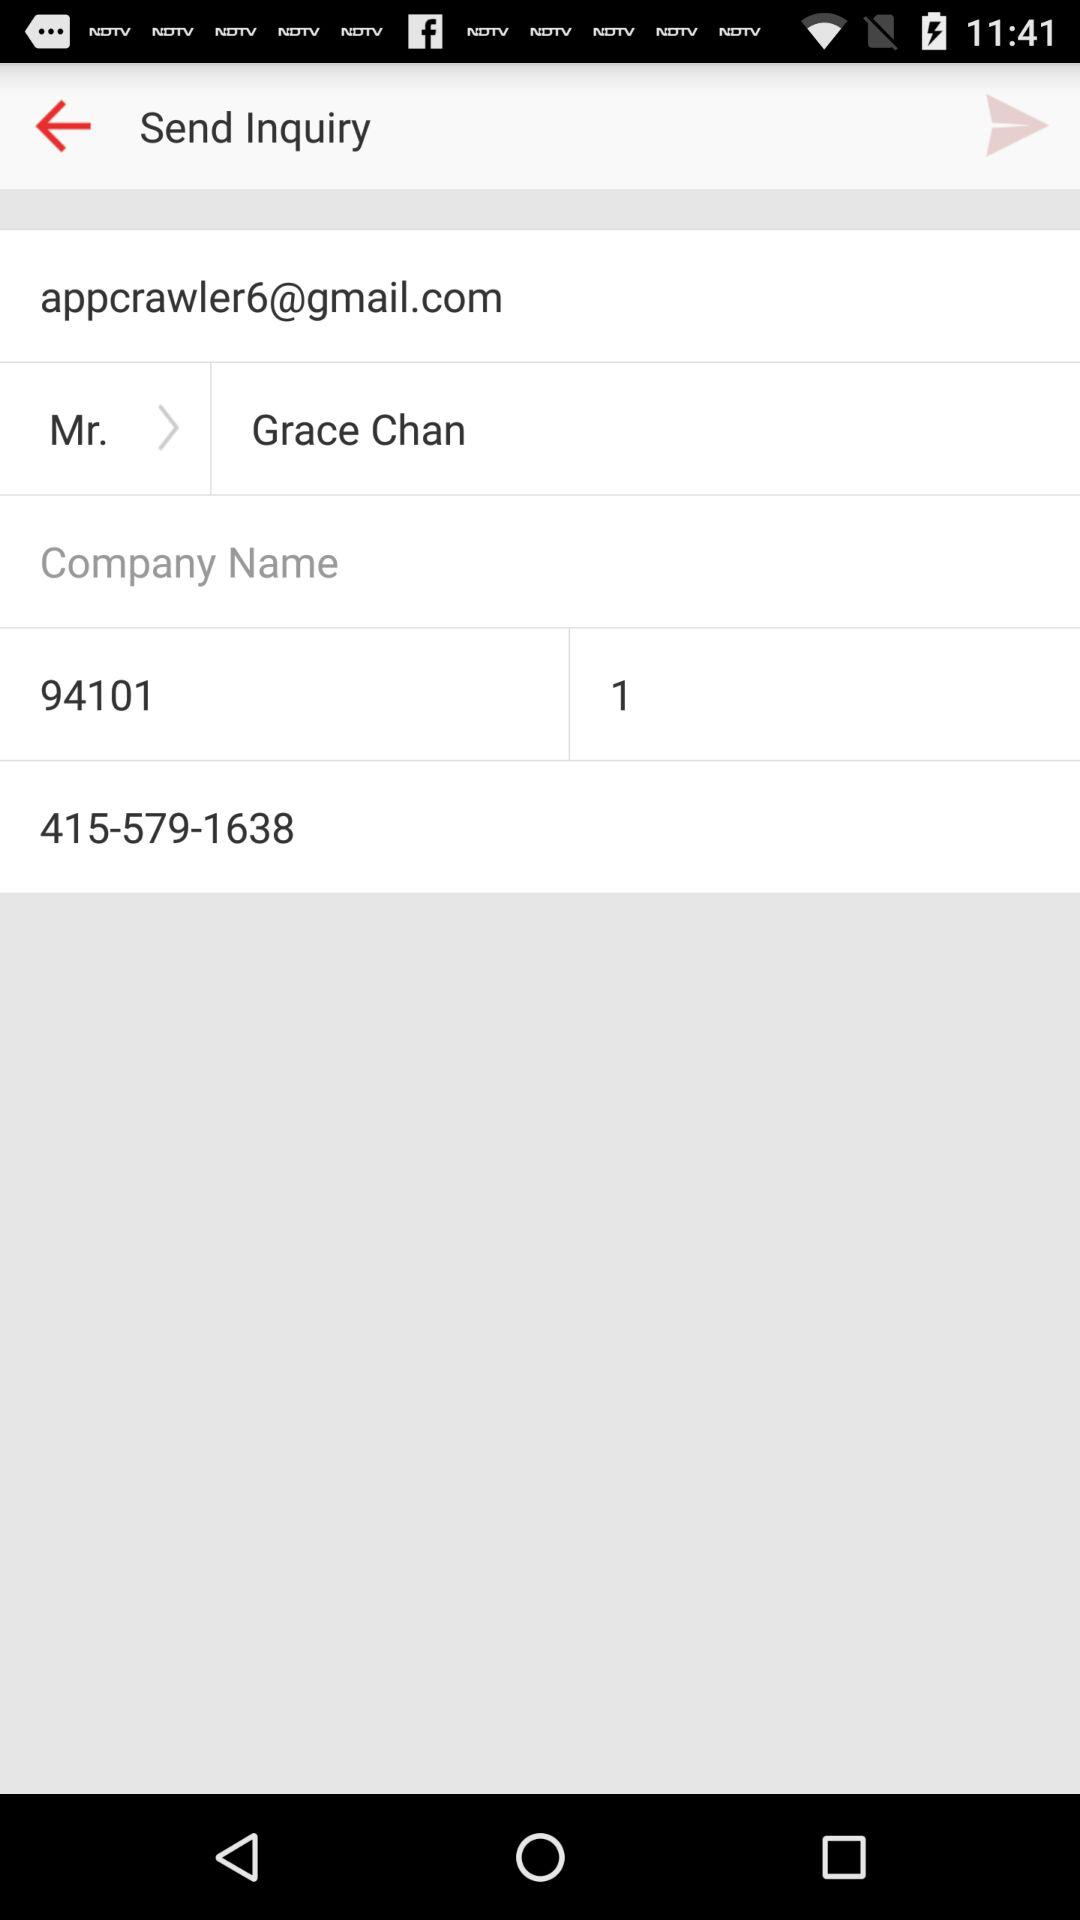What is the given contact number? The given contact number is 415-579-1638. 